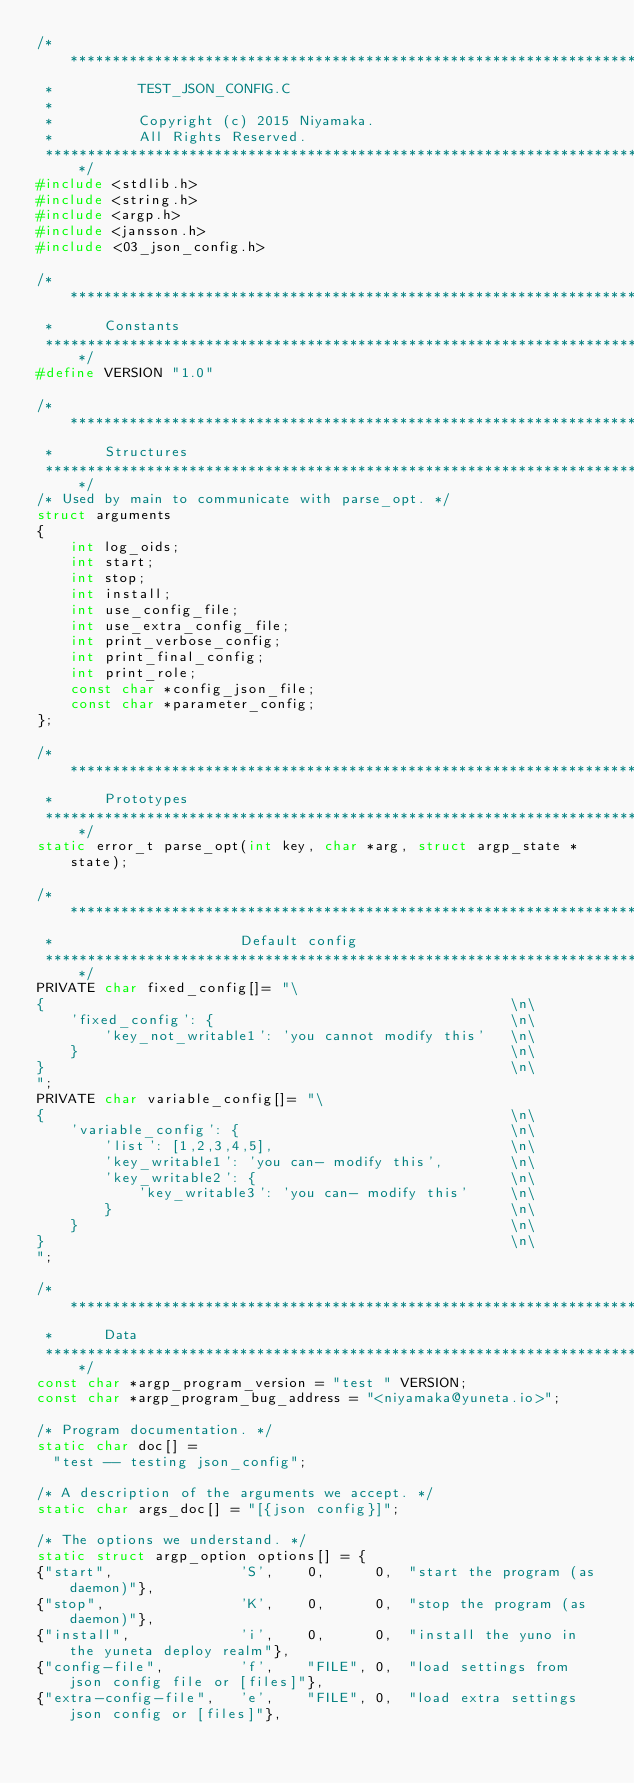Convert code to text. <code><loc_0><loc_0><loc_500><loc_500><_C_>/****************************************************************************
 *          TEST_JSON_CONFIG.C
 *
 *          Copyright (c) 2015 Niyamaka.
 *          All Rights Reserved.
 ****************************************************************************/
#include <stdlib.h>
#include <string.h>
#include <argp.h>
#include <jansson.h>
#include <03_json_config.h>

/***************************************************************************
 *      Constants
 ***************************************************************************/
#define VERSION "1.0"

/***************************************************************************
 *      Structures
 ***************************************************************************/
/* Used by main to communicate with parse_opt. */
struct arguments
{
    int log_oids;
    int start;
    int stop;
    int install;
    int use_config_file;
    int use_extra_config_file;
    int print_verbose_config;
    int print_final_config;
    int print_role;
    const char *config_json_file;
    const char *parameter_config;
};

/***************************************************************************
 *      Prototypes
 ***************************************************************************/
static error_t parse_opt(int key, char *arg, struct argp_state *state);

/***************************************************************************
 *                      Default config
 ***************************************************************************/
PRIVATE char fixed_config[]= "\
{                                                       \n\
    'fixed_config': {                                   \n\
        'key_not_writable1': 'you cannot modify this'   \n\
    }                                                   \n\
}                                                       \n\
";
PRIVATE char variable_config[]= "\
{                                                       \n\
    'variable_config': {                                \n\
        'list': [1,2,3,4,5],                            \n\
        'key_writable1': 'you can- modify this',        \n\
        'key_writable2': {                              \n\
            'key_writable3': 'you can- modify this'     \n\
        }                                               \n\
    }                                                   \n\
}                                                       \n\
";

/***************************************************************************
 *      Data
 ***************************************************************************/
const char *argp_program_version = "test " VERSION;
const char *argp_program_bug_address = "<niyamaka@yuneta.io>";

/* Program documentation. */
static char doc[] =
  "test -- testing json_config";

/* A description of the arguments we accept. */
static char args_doc[] = "[{json config}]";

/* The options we understand. */
static struct argp_option options[] = {
{"start",               'S',    0,      0,  "start the program (as daemon)"},
{"stop",                'K',    0,      0,  "stop the program (as daemon)"},
{"install",             'i',    0,      0,  "install the yuno in the yuneta deploy realm"},
{"config-file",         'f',    "FILE", 0,  "load settings from json config file or [files]"},
{"extra-config-file",   'e',    "FILE", 0,  "load extra settings json config or [files]"},</code> 